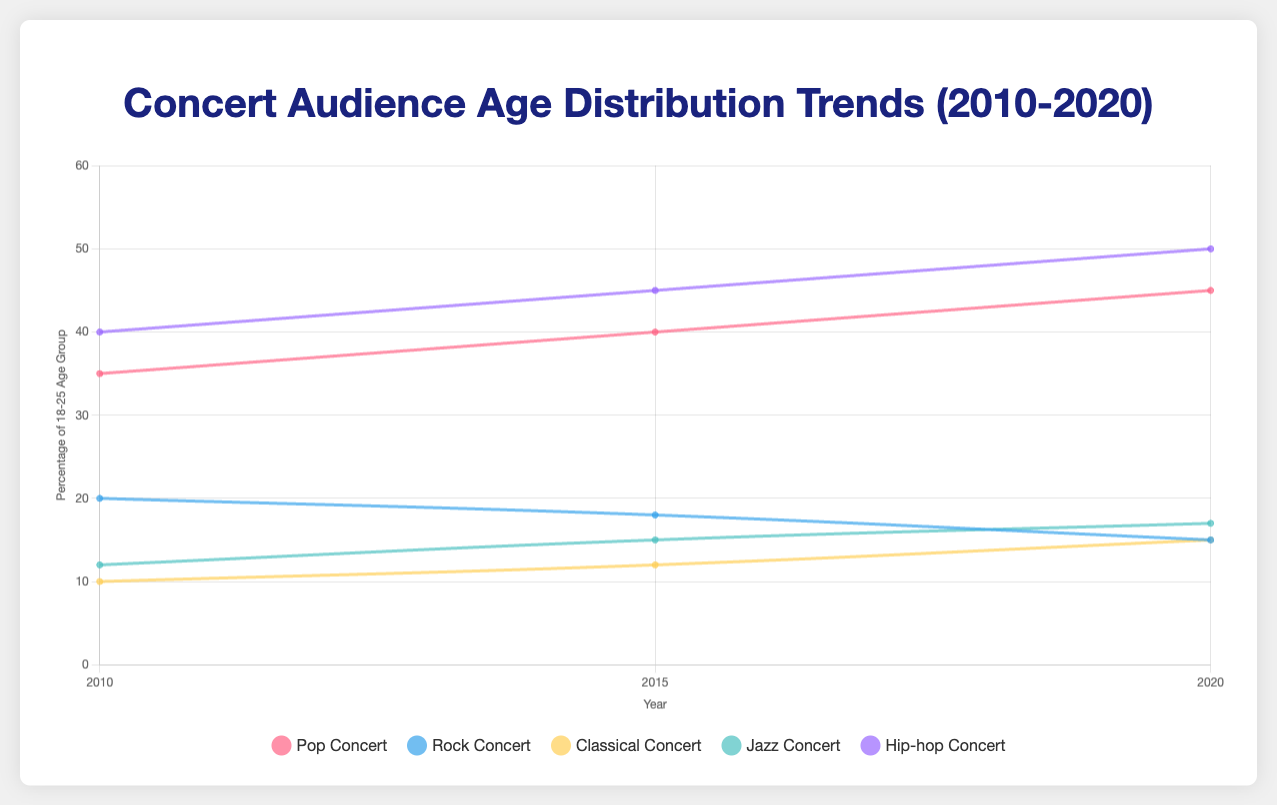Which concert type had the highest percentage of the 18-25 age group in 2020? Looking at the point on the y-axis for the year 2020 associated with each concert type's line, the highest point belongs to Hip-hop Concert.
Answer: Hip-hop Concert Between 2010 and 2020, which concert type saw the largest increase in the percentage of the 18-25 age group? Calculate the difference for each concert type: Pop (45-35)=10, Rock (15-20)=-5, Classical (15-10)=5, Jazz (17-12)=5, Hip-hop (50-40)=10. The largest increase is for both Pop and Hip-hop Concerts, which saw an increase of 10%.
Answer: Pop Concert and Hip-hop Concert In 2015, was the percentage of the 18-25 age group at Pop Concerts greater than or less than that for Rock Concerts? Compare the values on the y-axis for Pop and Rock Concerts in 2015. Pop Concerts had a percentage of 40, while Rock Concerts had a percentage of 18.
Answer: Greater Which age group showed the highest percentage for Classical Concerts in 2010? The age group percentages for Classical Concerts in 2010 can be checked in the figure. The highest bar belongs to the 46-60 age group.
Answer: 46-60 What is the average percentage of the 18-25 age group for Jazz Concerts over the years 2010, 2015, and 2020? Sum the percentages and then divide by 3: (12 + 15 + 17) / 3 = 44 / 3 ≈ 14.67.
Answer: ~14.67 Which concert type experienced a decrease in the percentage of the 18-25 age group between 2010 and 2015? Calculate the difference: Pop (40-35)=5, Rock (18-20)=-2, Classical (12-10)=2, Jazz (15-12)=3, Hip-hop (45-40)=5. The Rock Concerts saw a decrease.
Answer: Rock Concert Comparing 2020, which concert type has the smallest percentage of the 60+ age group? Check the lowest point among the lines representing the 60+ age group in 2020. The smallest percentage, 1, is for Hip-hop Concert.
Answer: Hip-hop Concert Is the trend for the percentage of the 18-25 age group in Pop Concerts increasing, decreasing, or fluctuating between 2010 and 2020? Examine the slope of the line for Pop Concerts from 2010 to 2020. The slope is consistently upward, indicating an increasing trend.
Answer: Increasing 